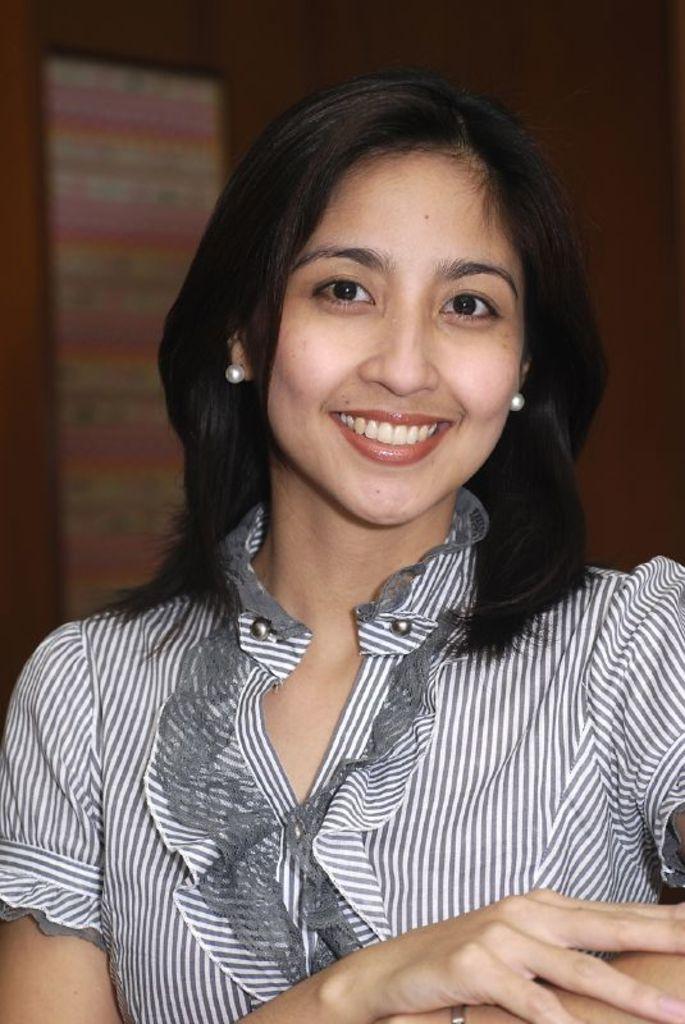How would you summarize this image in a sentence or two? In this image in the foreground there is one woman who is smiling, and the background is blurry but we could see a board and wall. 